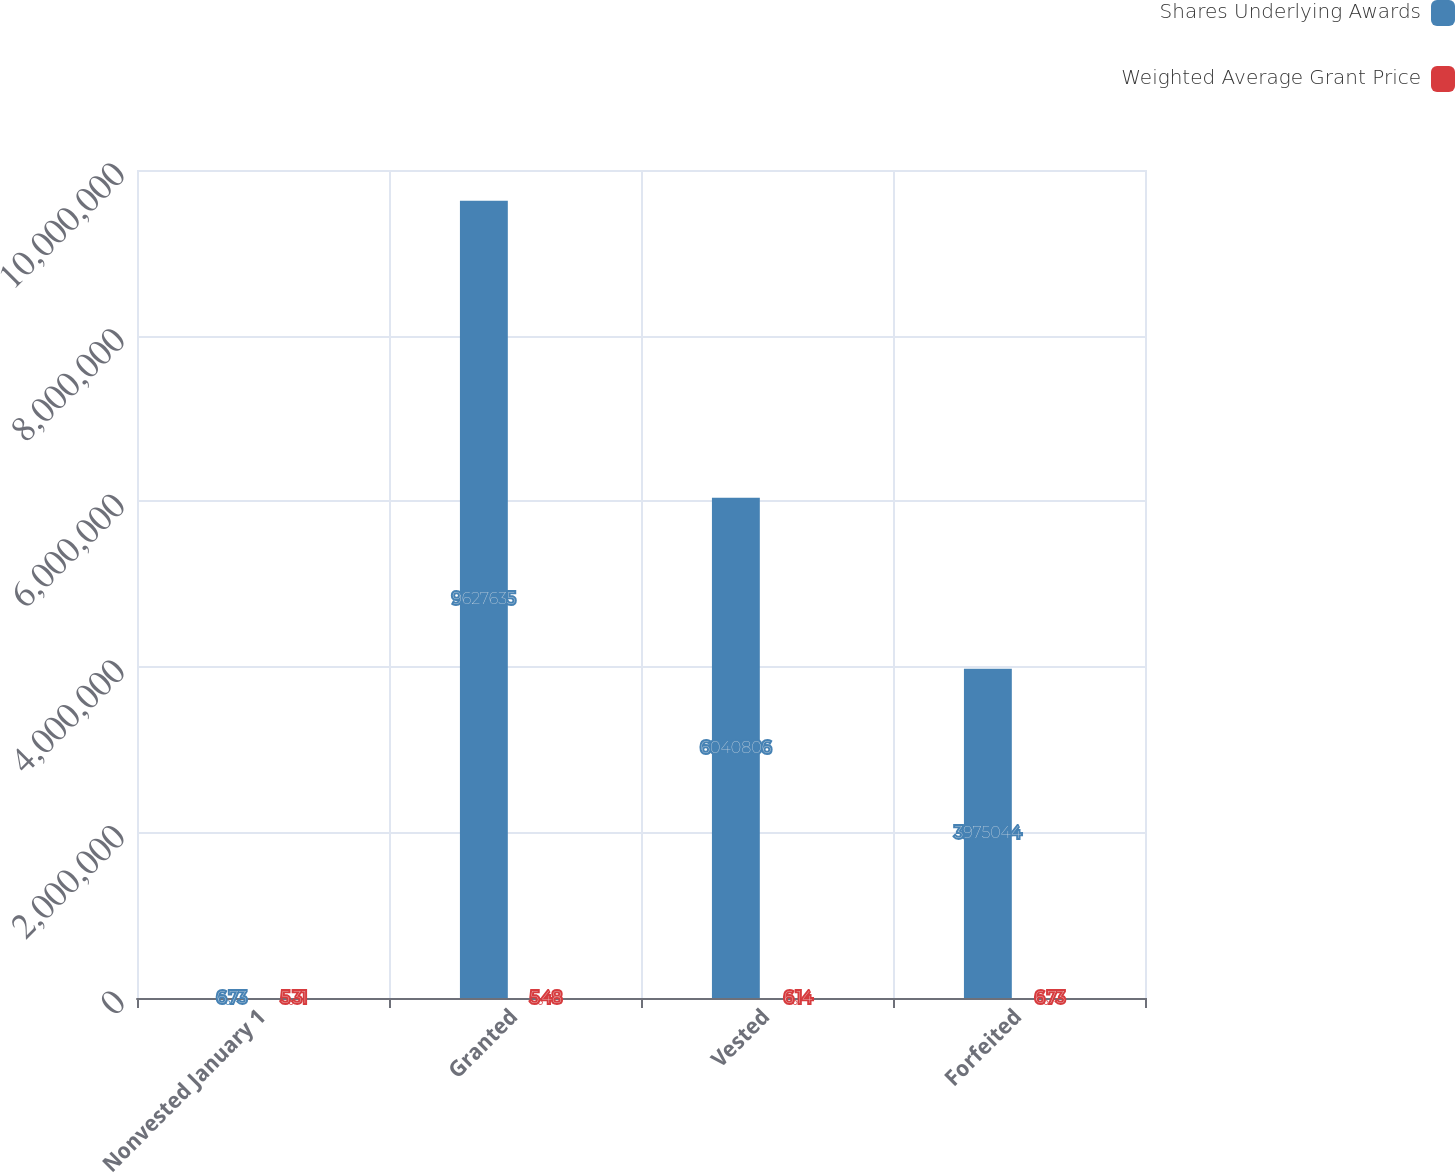Convert chart to OTSL. <chart><loc_0><loc_0><loc_500><loc_500><stacked_bar_chart><ecel><fcel>Nonvested January 1<fcel>Granted<fcel>Vested<fcel>Forfeited<nl><fcel>Shares Underlying Awards<fcel>6.73<fcel>9.62764e+06<fcel>6.04081e+06<fcel>3.97504e+06<nl><fcel>Weighted Average Grant Price<fcel>5.31<fcel>5.48<fcel>6.14<fcel>6.73<nl></chart> 